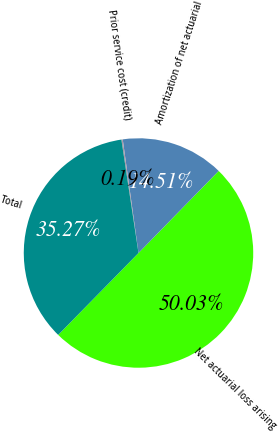Convert chart to OTSL. <chart><loc_0><loc_0><loc_500><loc_500><pie_chart><fcel>Net actuarial loss arising<fcel>Amortization of net actuarial<fcel>Prior service cost (credit)<fcel>Total<nl><fcel>50.03%<fcel>14.51%<fcel>0.19%<fcel>35.27%<nl></chart> 